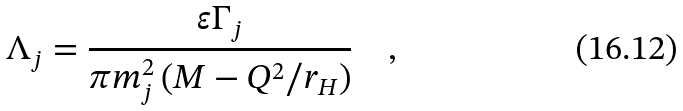<formula> <loc_0><loc_0><loc_500><loc_500>\Lambda _ { j } = \frac { \varepsilon \Gamma _ { j } } { \pi m _ { j } ^ { 2 } \left ( M - Q ^ { 2 } / r _ { H } \right ) } \quad ,</formula> 